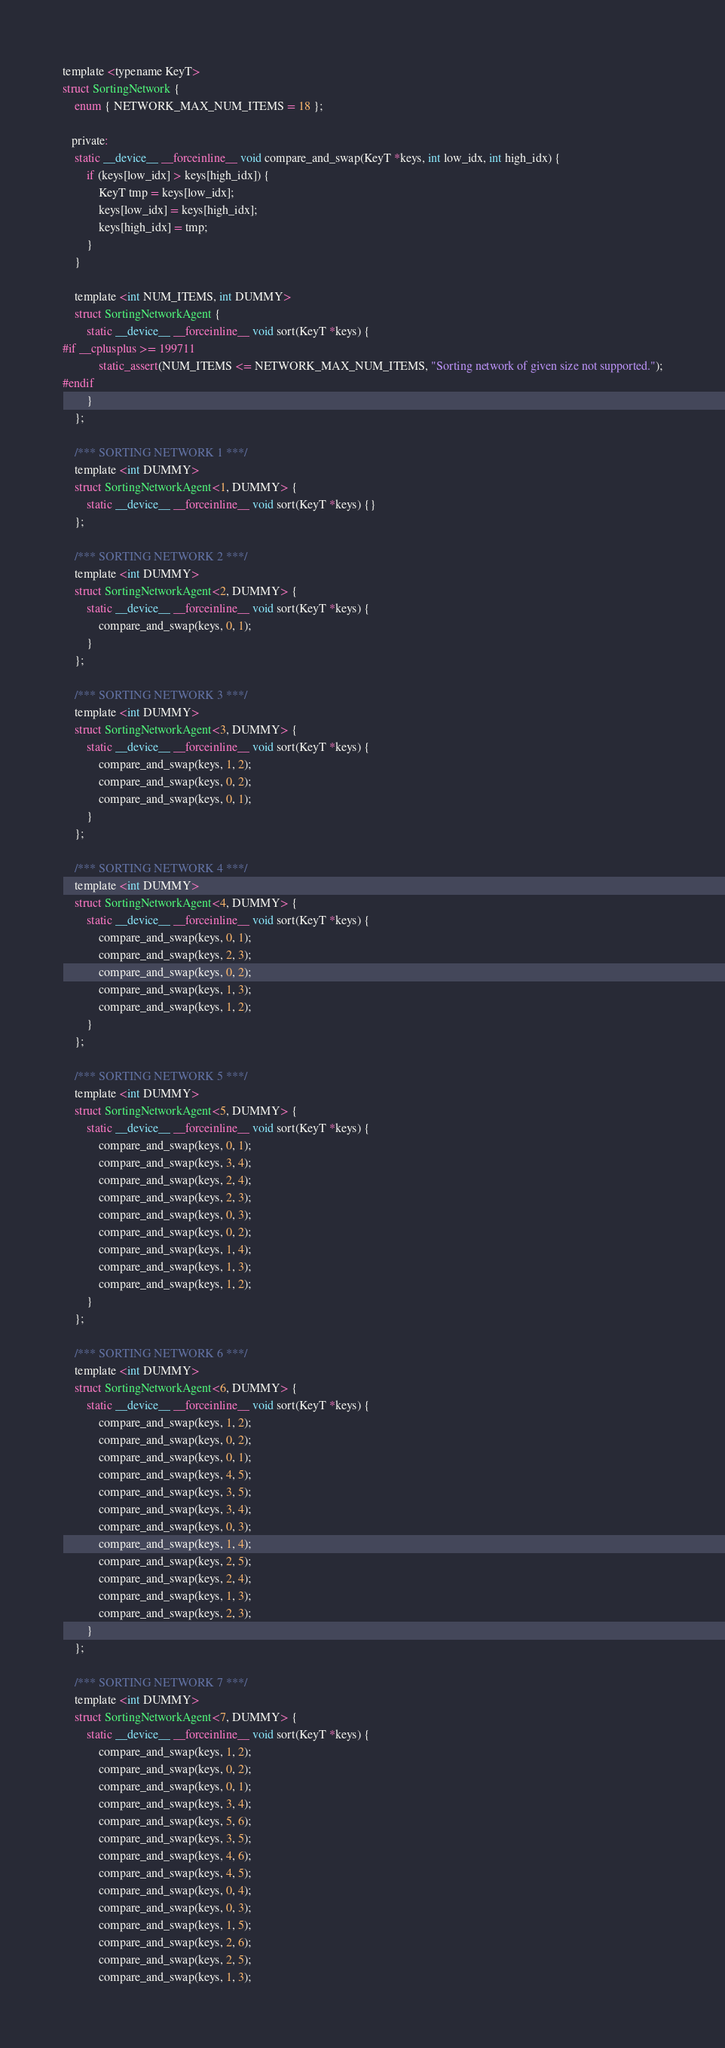Convert code to text. <code><loc_0><loc_0><loc_500><loc_500><_Cuda_>template <typename KeyT>
struct SortingNetwork {
    enum { NETWORK_MAX_NUM_ITEMS = 18 };

   private:
    static __device__ __forceinline__ void compare_and_swap(KeyT *keys, int low_idx, int high_idx) {
        if (keys[low_idx] > keys[high_idx]) {
            KeyT tmp = keys[low_idx];
            keys[low_idx] = keys[high_idx];
            keys[high_idx] = tmp;
        }
    }

    template <int NUM_ITEMS, int DUMMY>
    struct SortingNetworkAgent {
        static __device__ __forceinline__ void sort(KeyT *keys) {
#if __cplusplus >= 199711
            static_assert(NUM_ITEMS <= NETWORK_MAX_NUM_ITEMS, "Sorting network of given size not supported.");
#endif
        }
    };

    /*** SORTING NETWORK 1 ***/
    template <int DUMMY>
    struct SortingNetworkAgent<1, DUMMY> {
        static __device__ __forceinline__ void sort(KeyT *keys) {}
    };

    /*** SORTING NETWORK 2 ***/
    template <int DUMMY>
    struct SortingNetworkAgent<2, DUMMY> {
        static __device__ __forceinline__ void sort(KeyT *keys) {
            compare_and_swap(keys, 0, 1);
        }
    };

    /*** SORTING NETWORK 3 ***/
    template <int DUMMY>
    struct SortingNetworkAgent<3, DUMMY> {
        static __device__ __forceinline__ void sort(KeyT *keys) {
            compare_and_swap(keys, 1, 2);
            compare_and_swap(keys, 0, 2);
            compare_and_swap(keys, 0, 1);
        }
    };

    /*** SORTING NETWORK 4 ***/
    template <int DUMMY>
    struct SortingNetworkAgent<4, DUMMY> {
        static __device__ __forceinline__ void sort(KeyT *keys) {
            compare_and_swap(keys, 0, 1);
            compare_and_swap(keys, 2, 3);
            compare_and_swap(keys, 0, 2);
            compare_and_swap(keys, 1, 3);
            compare_and_swap(keys, 1, 2);
        }
    };

    /*** SORTING NETWORK 5 ***/
    template <int DUMMY>
    struct SortingNetworkAgent<5, DUMMY> {
        static __device__ __forceinline__ void sort(KeyT *keys) {
            compare_and_swap(keys, 0, 1);
            compare_and_swap(keys, 3, 4);
            compare_and_swap(keys, 2, 4);
            compare_and_swap(keys, 2, 3);
            compare_and_swap(keys, 0, 3);
            compare_and_swap(keys, 0, 2);
            compare_and_swap(keys, 1, 4);
            compare_and_swap(keys, 1, 3);
            compare_and_swap(keys, 1, 2);
        }
    };

    /*** SORTING NETWORK 6 ***/
    template <int DUMMY>
    struct SortingNetworkAgent<6, DUMMY> {
        static __device__ __forceinline__ void sort(KeyT *keys) {
            compare_and_swap(keys, 1, 2);
            compare_and_swap(keys, 0, 2);
            compare_and_swap(keys, 0, 1);
            compare_and_swap(keys, 4, 5);
            compare_and_swap(keys, 3, 5);
            compare_and_swap(keys, 3, 4);
            compare_and_swap(keys, 0, 3);
            compare_and_swap(keys, 1, 4);
            compare_and_swap(keys, 2, 5);
            compare_and_swap(keys, 2, 4);
            compare_and_swap(keys, 1, 3);
            compare_and_swap(keys, 2, 3);
        }
    };

    /*** SORTING NETWORK 7 ***/
    template <int DUMMY>
    struct SortingNetworkAgent<7, DUMMY> {
        static __device__ __forceinline__ void sort(KeyT *keys) {
            compare_and_swap(keys, 1, 2);
            compare_and_swap(keys, 0, 2);
            compare_and_swap(keys, 0, 1);
            compare_and_swap(keys, 3, 4);
            compare_and_swap(keys, 5, 6);
            compare_and_swap(keys, 3, 5);
            compare_and_swap(keys, 4, 6);
            compare_and_swap(keys, 4, 5);
            compare_and_swap(keys, 0, 4);
            compare_and_swap(keys, 0, 3);
            compare_and_swap(keys, 1, 5);
            compare_and_swap(keys, 2, 6);
            compare_and_swap(keys, 2, 5);
            compare_and_swap(keys, 1, 3);</code> 